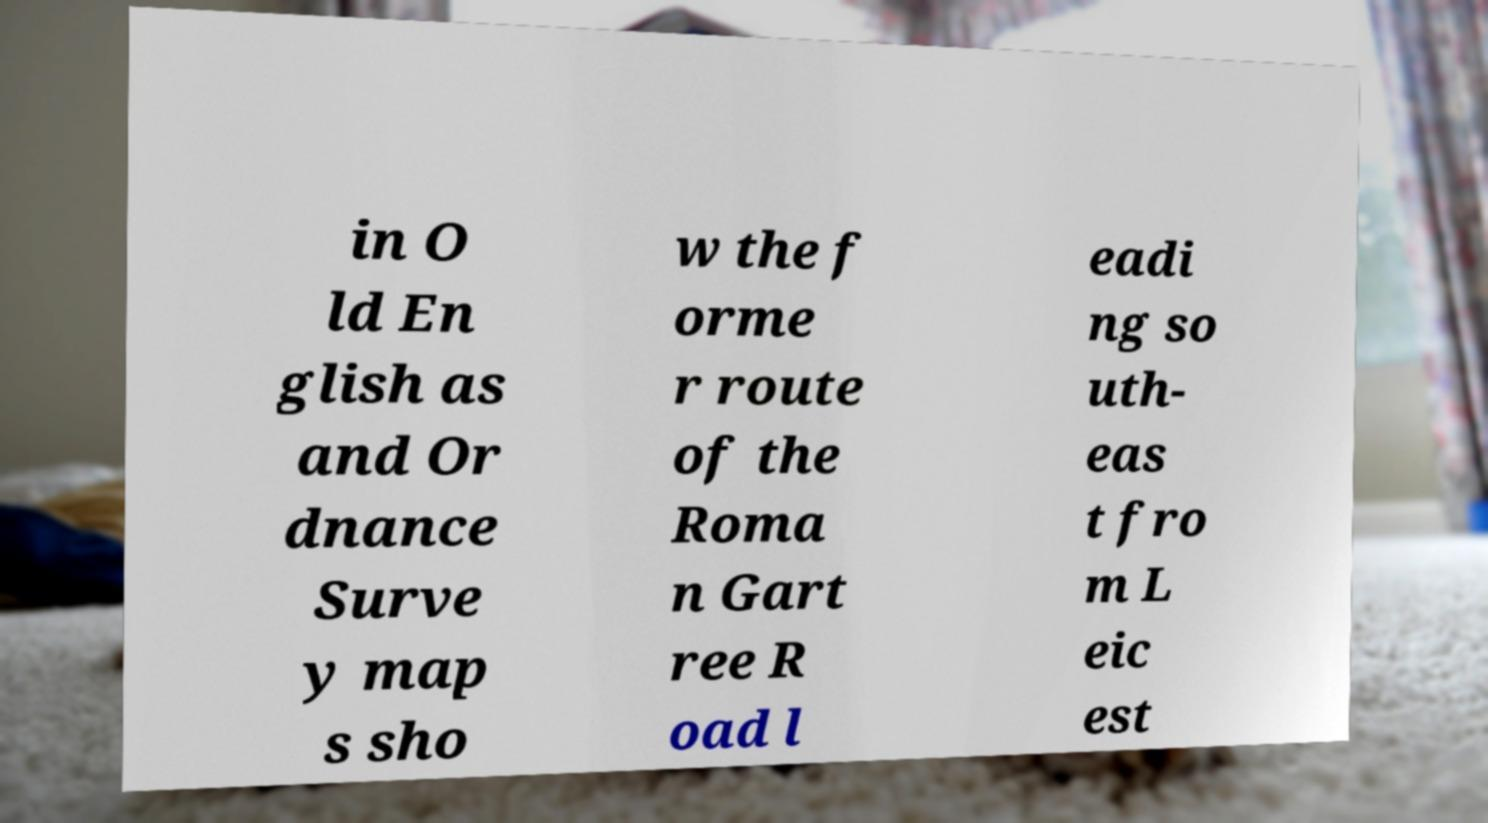Can you read and provide the text displayed in the image?This photo seems to have some interesting text. Can you extract and type it out for me? in O ld En glish as and Or dnance Surve y map s sho w the f orme r route of the Roma n Gart ree R oad l eadi ng so uth- eas t fro m L eic est 